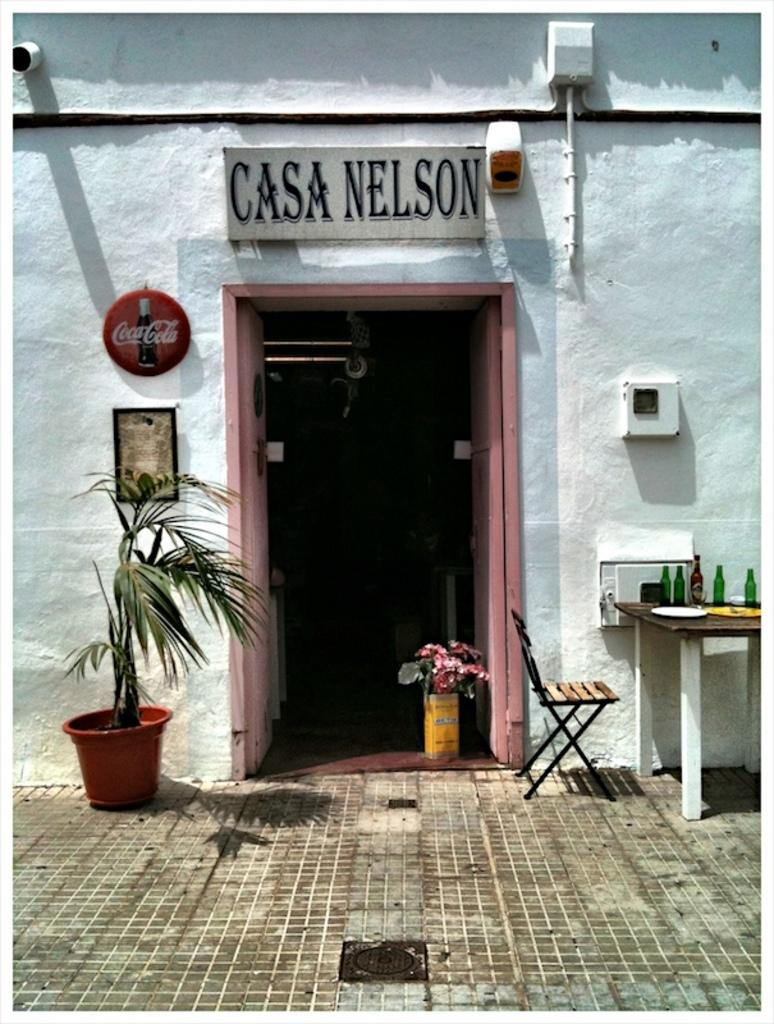What type of structure is visible in the image? There is a building in the image. What type of vegetation is present in the image? There is a plant in the image. What type of furniture is visible in the image? There is a chair in the image. What items can be seen on a table in the image? There are bottles on a table in the image. What type of sign is present in the image? There is a name board in the image. Can you describe the haircut of the person sitting on the sofa in the image? There is no person or sofa present in the image. What type of trip is being taken by the individuals in the image? There are no individuals or trips present in the image. 